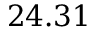<formula> <loc_0><loc_0><loc_500><loc_500>2 4 . 3 1</formula> 